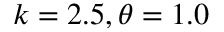<formula> <loc_0><loc_0><loc_500><loc_500>k = 2 . 5 , \theta = 1 . 0</formula> 